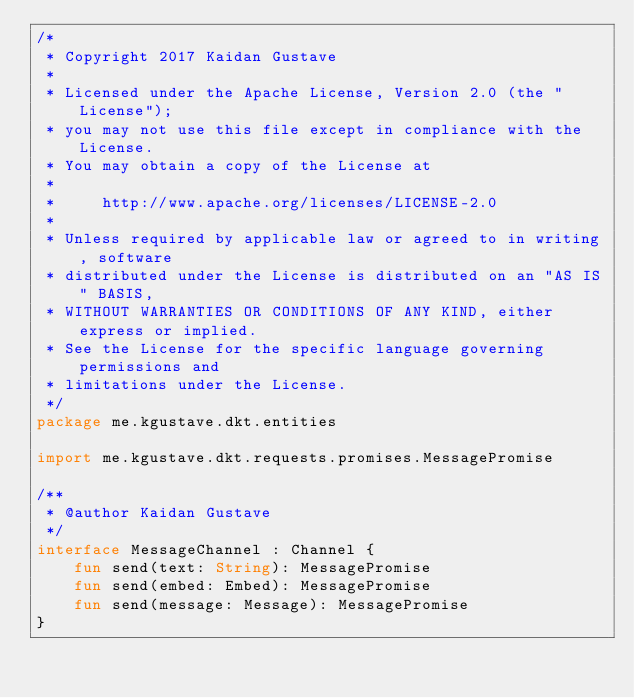Convert code to text. <code><loc_0><loc_0><loc_500><loc_500><_Kotlin_>/*
 * Copyright 2017 Kaidan Gustave
 *
 * Licensed under the Apache License, Version 2.0 (the "License");
 * you may not use this file except in compliance with the License.
 * You may obtain a copy of the License at
 *
 *     http://www.apache.org/licenses/LICENSE-2.0
 *
 * Unless required by applicable law or agreed to in writing, software
 * distributed under the License is distributed on an "AS IS" BASIS,
 * WITHOUT WARRANTIES OR CONDITIONS OF ANY KIND, either express or implied.
 * See the License for the specific language governing permissions and
 * limitations under the License.
 */
package me.kgustave.dkt.entities

import me.kgustave.dkt.requests.promises.MessagePromise

/**
 * @author Kaidan Gustave
 */
interface MessageChannel : Channel {
    fun send(text: String): MessagePromise
    fun send(embed: Embed): MessagePromise
    fun send(message: Message): MessagePromise
}
</code> 